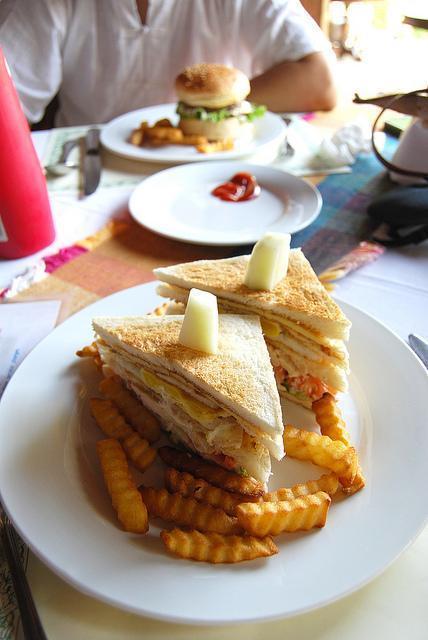What is used the make the fries have that shape?
Indicate the correct response by choosing from the four available options to answer the question.
Options: Crinkle cutter, spatula, fork, steak knife. Crinkle cutter. 